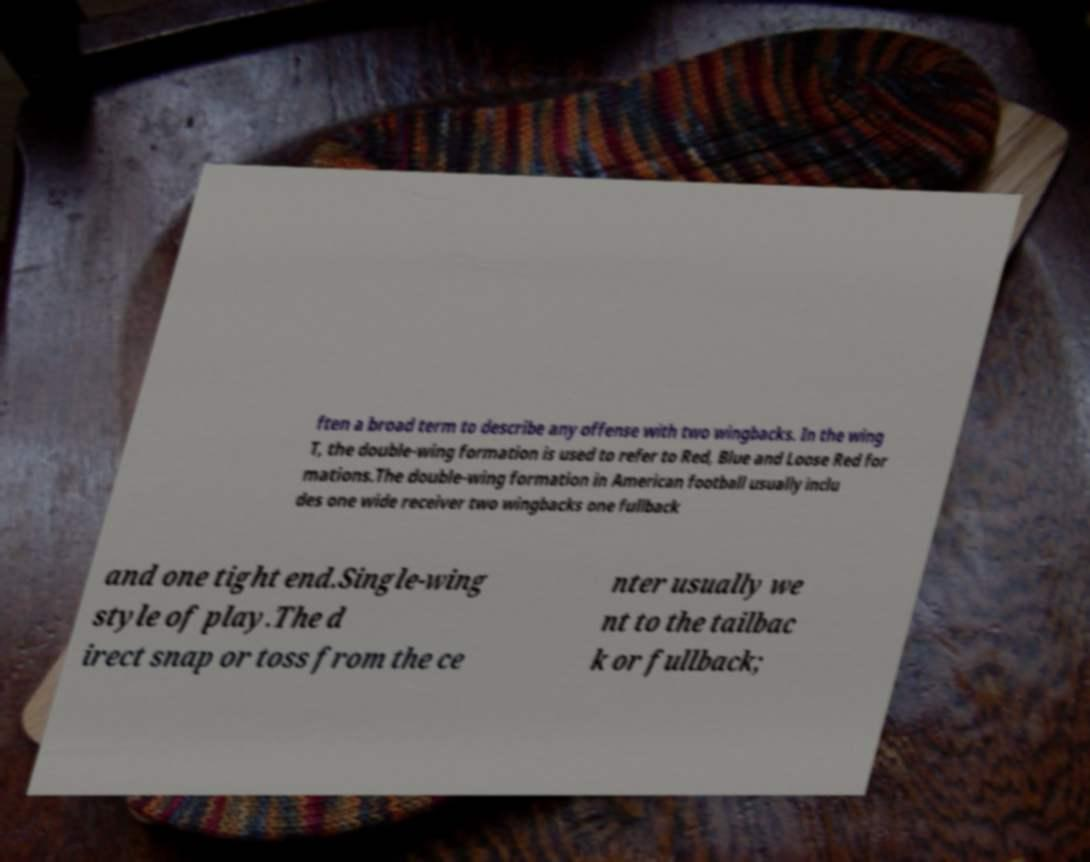What messages or text are displayed in this image? I need them in a readable, typed format. ften a broad term to describe any offense with two wingbacks. In the wing T, the double-wing formation is used to refer to Red, Blue and Loose Red for mations.The double-wing formation in American football usually inclu des one wide receiver two wingbacks one fullback and one tight end.Single-wing style of play.The d irect snap or toss from the ce nter usually we nt to the tailbac k or fullback; 